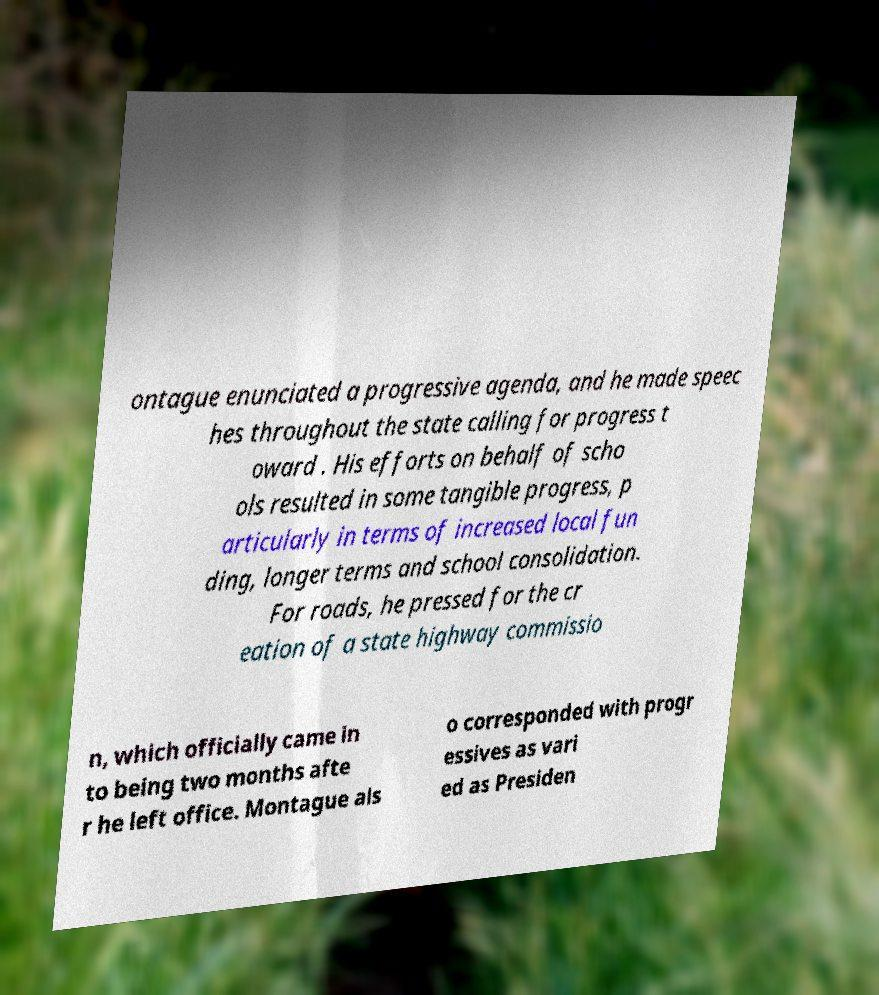For documentation purposes, I need the text within this image transcribed. Could you provide that? ontague enunciated a progressive agenda, and he made speec hes throughout the state calling for progress t oward . His efforts on behalf of scho ols resulted in some tangible progress, p articularly in terms of increased local fun ding, longer terms and school consolidation. For roads, he pressed for the cr eation of a state highway commissio n, which officially came in to being two months afte r he left office. Montague als o corresponded with progr essives as vari ed as Presiden 